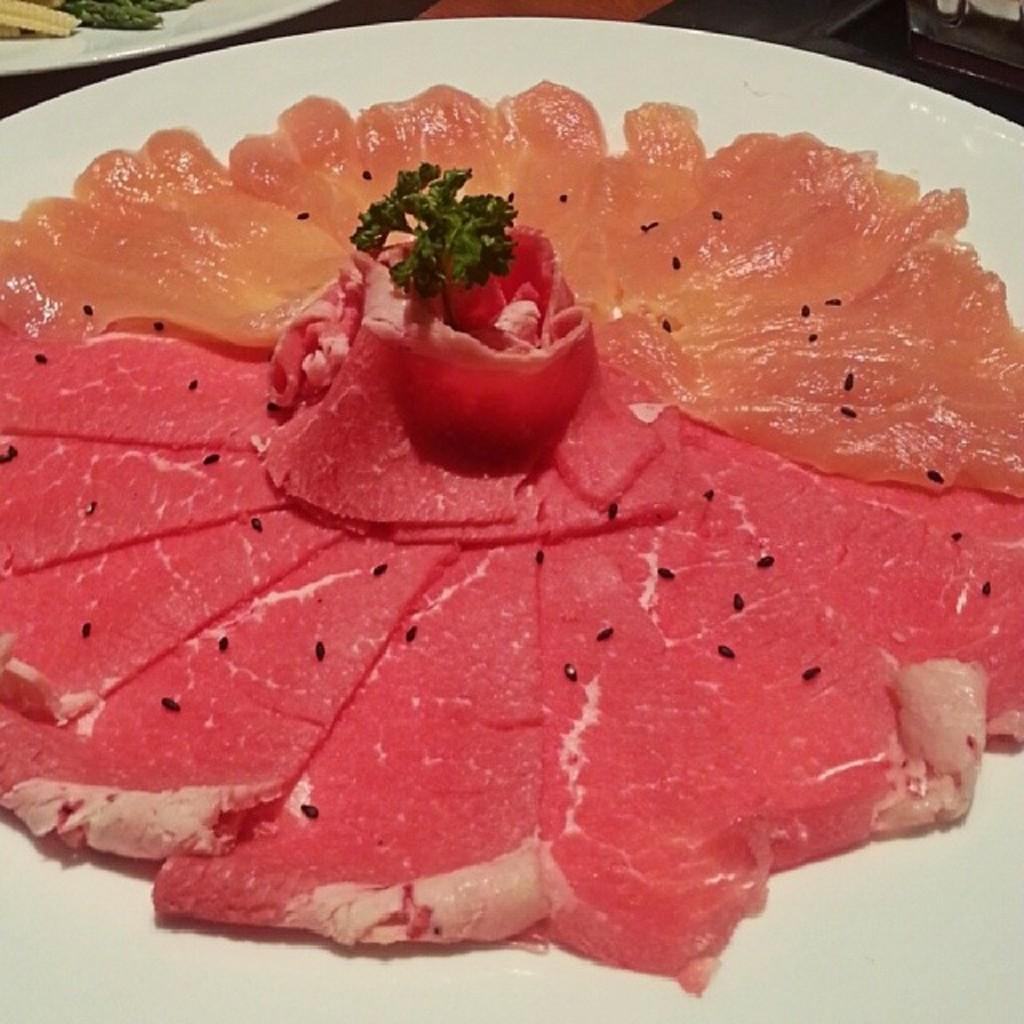What is on the plate in the image? There is meat on the plate. Is there anything else on the plate besides the meat? Yes, there is jelly on the plate. How is the jelly arranged on the plate? The jelly is in the form of a flower. Where is the meat located on the plate? The meat is at the bottom of the plate. Is the throne made of the same material as the jelly on the plate? There is no throne present in the image, so we cannot compare its material to the jelly. 